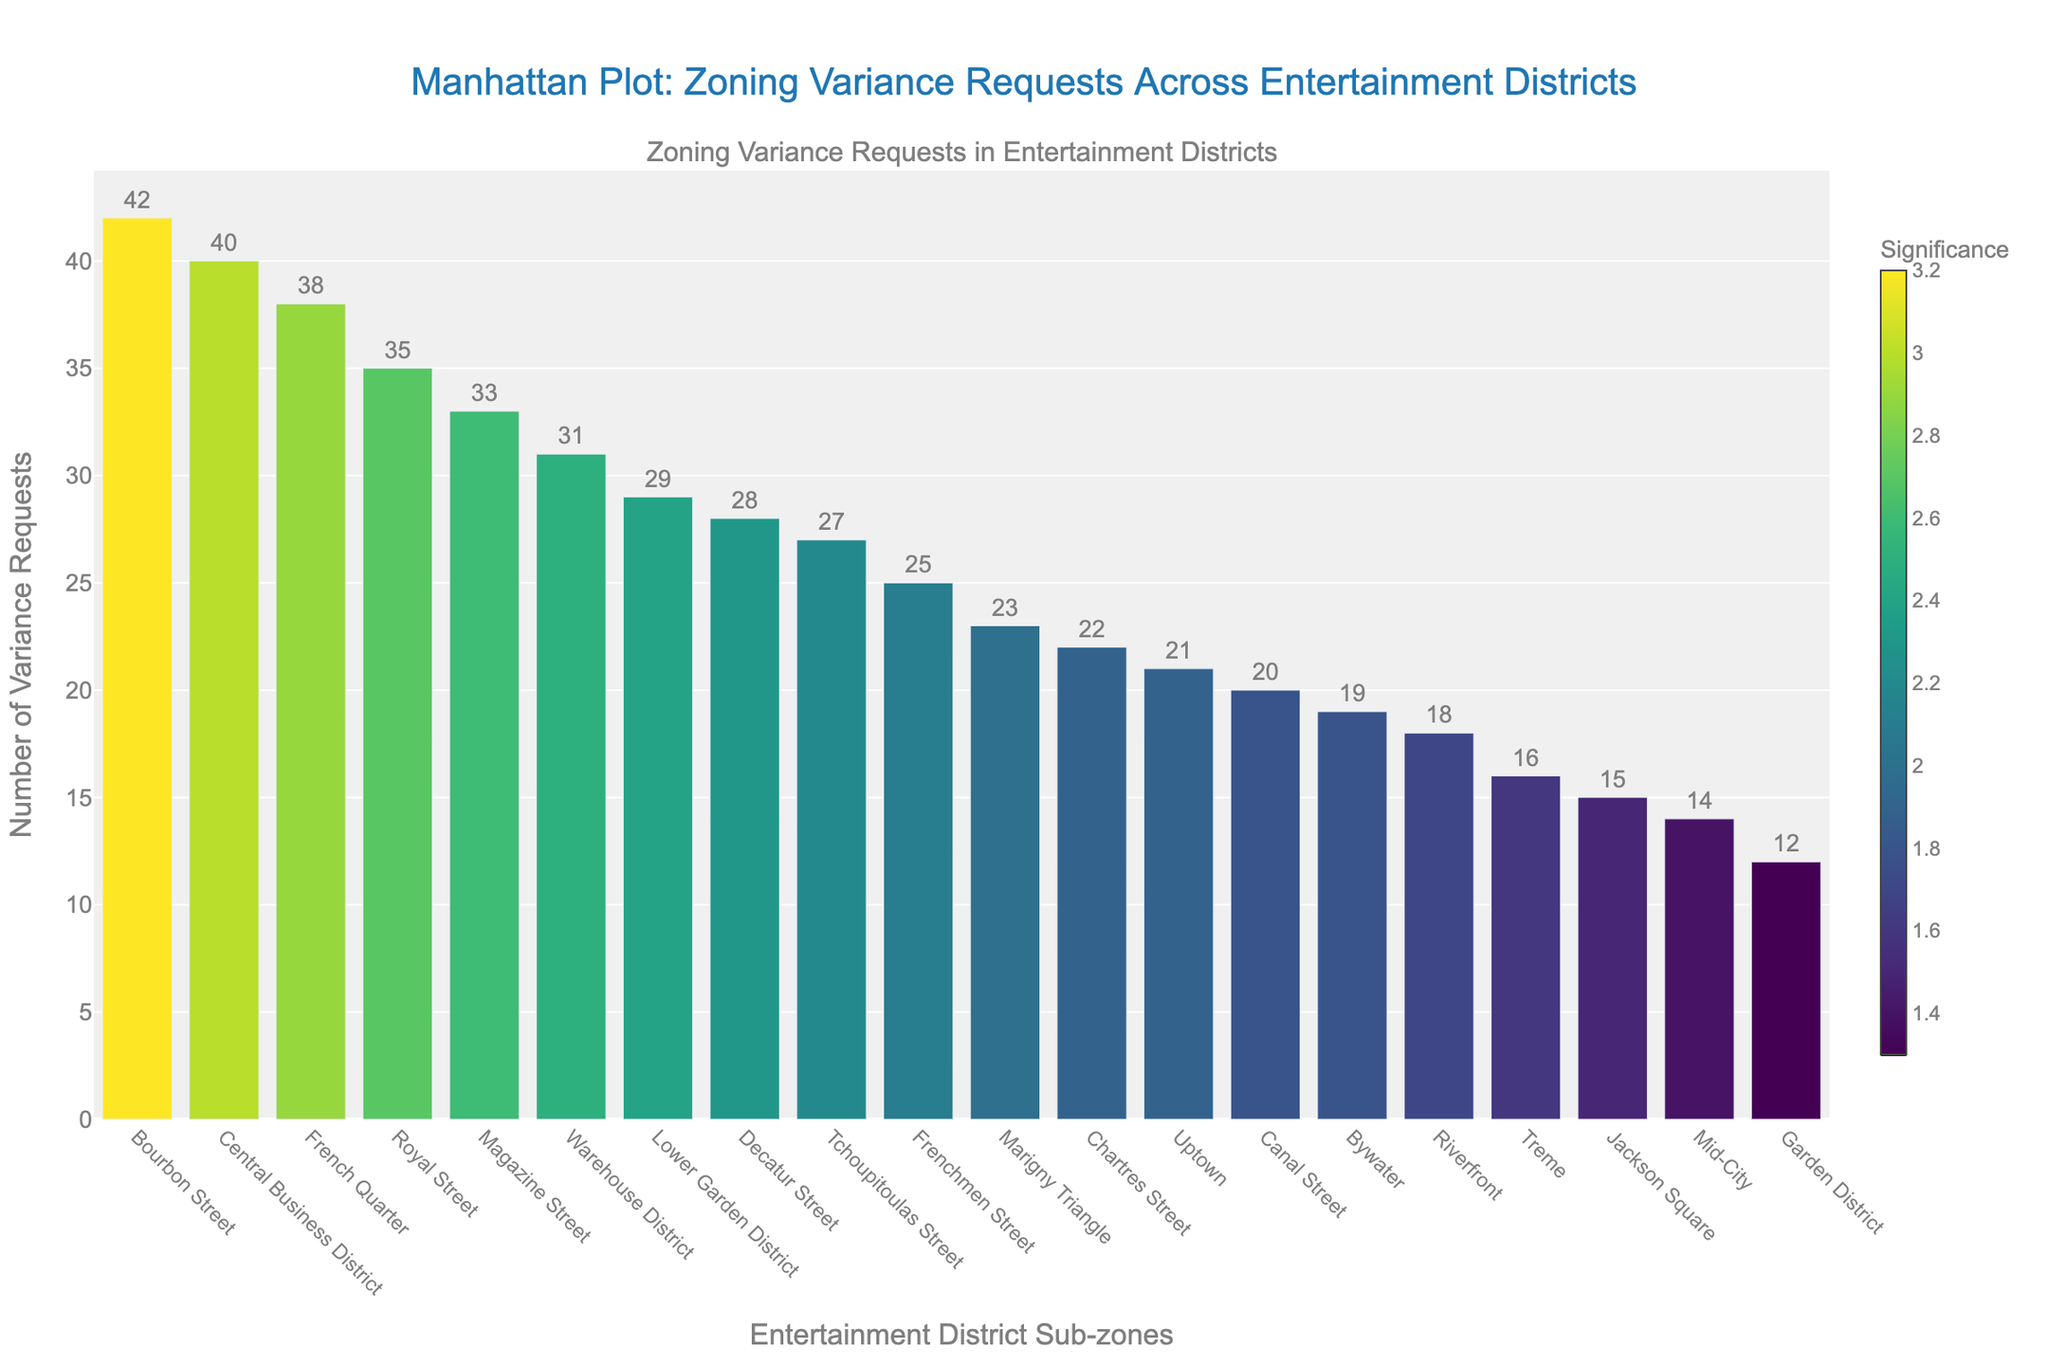How many sub-zones are represented in the figure? Count the total number of distinct sub-zones along the x-axis. Each bar represents a sub-zone.
Answer: 20 Which sub-zone has the highest number of variance requests? Identify the bar with the highest y-value. Bourbon Street has the tallest bar indicating it has the highest number of variance requests.
Answer: Bourbon Street What is the average number of variance requests across all sub-zones? Sum all the variance requests and divide by the number of sub-zones. (42 + 38 + 25 + 31 + 20 + 28 + 22 + 35 + 15 + 18 + 33 + 12 + 27 + 40 + 23 + 19 + 16 + 14 + 21 + 29) / 20 = 27.1
Answer: 27.1 How does the number of variance requests for Jackson Square compare to Canal Street? Look at the y-values for Jackson Square (15) and Canal Street (20). Canal Street has more variance requests than Jackson Square.
Answer: Canal Street has more What color represents sub-zones with the highest significance? Examine the color gradient and identify which color corresponds to the highest significance values. Sub-zones with significance around 3.2 are in the darkest color of the Viridis scale.
Answer: Dark purple Which sub-zone has the lowest significance score, and what is that score? Identify the bar with the lowest significance color and check the corresponding hover information. Garden District has the lightest color corresponding to a significance of 1.3.
Answer: Garden District, 1.3 What is the combined number of variance requests for sub-zones with significance scores greater than 2.5? Sum the number of variance requests for all sub-zones with significance scores greater than 2.5. This includes Bourbon Street (42), French Quarter (38), Royal Street (35), Central Business District (40), and Magazine Street (33). 42 + 38 + 35 + 40 + 33 = 188
Answer: 188 Which sub-zone is the least significant but has more than 20 variance requests? Find the sub-zone with a significance score closest to the lower threshold (1.9) but with variance requests greater than 20. Uptown fits this description.
Answer: Uptown How does the variance request trend correlate with significance scores? Observe the color gradient of the bars: darker bars (higher significance scores) tend to be associated with taller bars (higher variance requests).
Answer: Positive correlation 